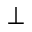<formula> <loc_0><loc_0><loc_500><loc_500>\perp</formula> 